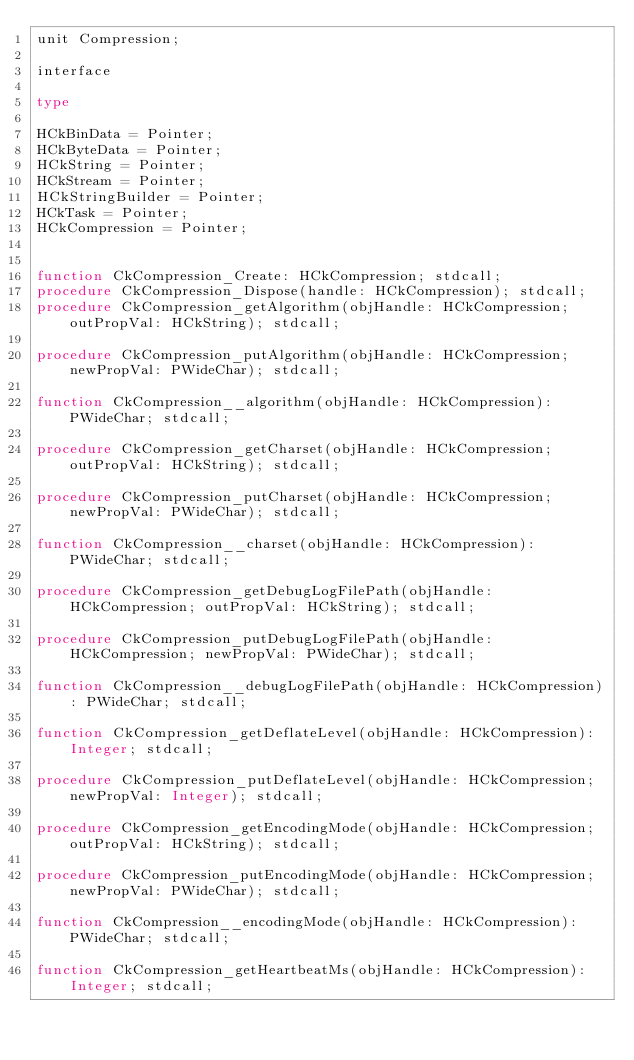Convert code to text. <code><loc_0><loc_0><loc_500><loc_500><_Pascal_>unit Compression;

interface

type

HCkBinData = Pointer;
HCkByteData = Pointer;
HCkString = Pointer;
HCkStream = Pointer;
HCkStringBuilder = Pointer;
HCkTask = Pointer;
HCkCompression = Pointer;


function CkCompression_Create: HCkCompression; stdcall;
procedure CkCompression_Dispose(handle: HCkCompression); stdcall;
procedure CkCompression_getAlgorithm(objHandle: HCkCompression; outPropVal: HCkString); stdcall;

procedure CkCompression_putAlgorithm(objHandle: HCkCompression; newPropVal: PWideChar); stdcall;

function CkCompression__algorithm(objHandle: HCkCompression): PWideChar; stdcall;

procedure CkCompression_getCharset(objHandle: HCkCompression; outPropVal: HCkString); stdcall;

procedure CkCompression_putCharset(objHandle: HCkCompression; newPropVal: PWideChar); stdcall;

function CkCompression__charset(objHandle: HCkCompression): PWideChar; stdcall;

procedure CkCompression_getDebugLogFilePath(objHandle: HCkCompression; outPropVal: HCkString); stdcall;

procedure CkCompression_putDebugLogFilePath(objHandle: HCkCompression; newPropVal: PWideChar); stdcall;

function CkCompression__debugLogFilePath(objHandle: HCkCompression): PWideChar; stdcall;

function CkCompression_getDeflateLevel(objHandle: HCkCompression): Integer; stdcall;

procedure CkCompression_putDeflateLevel(objHandle: HCkCompression; newPropVal: Integer); stdcall;

procedure CkCompression_getEncodingMode(objHandle: HCkCompression; outPropVal: HCkString); stdcall;

procedure CkCompression_putEncodingMode(objHandle: HCkCompression; newPropVal: PWideChar); stdcall;

function CkCompression__encodingMode(objHandle: HCkCompression): PWideChar; stdcall;

function CkCompression_getHeartbeatMs(objHandle: HCkCompression): Integer; stdcall;
</code> 